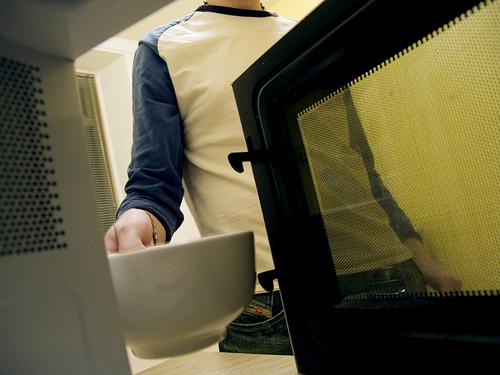Is he placing the bowl or removing it?
Short answer required. Placing. What is in the bowl?
Answer briefly. Soup. How many dots are on the left side of the microwave?
Give a very brief answer. 125. Is a male or a female looking into the microwave?
Answer briefly. Male. 